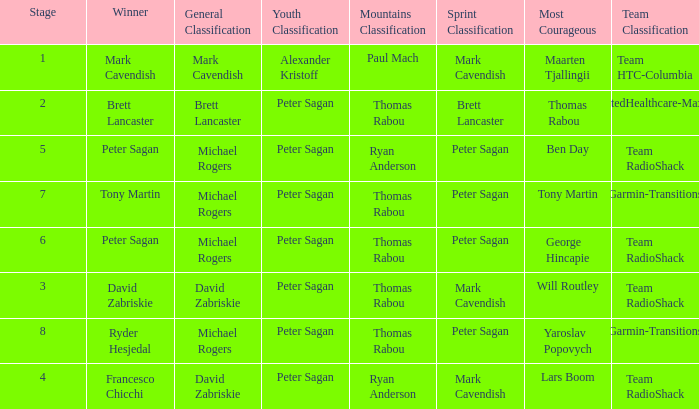When Mark Cavendish wins sprint classification and Maarten Tjallingii wins most courageous, who wins youth classification? Alexander Kristoff. 